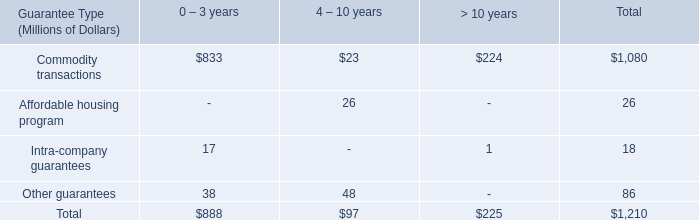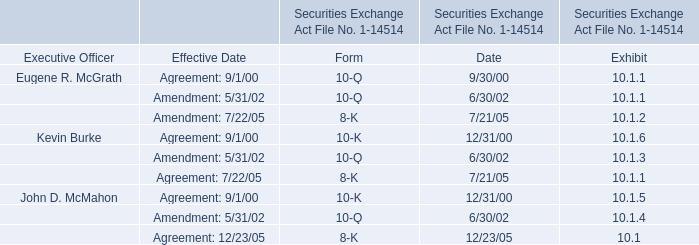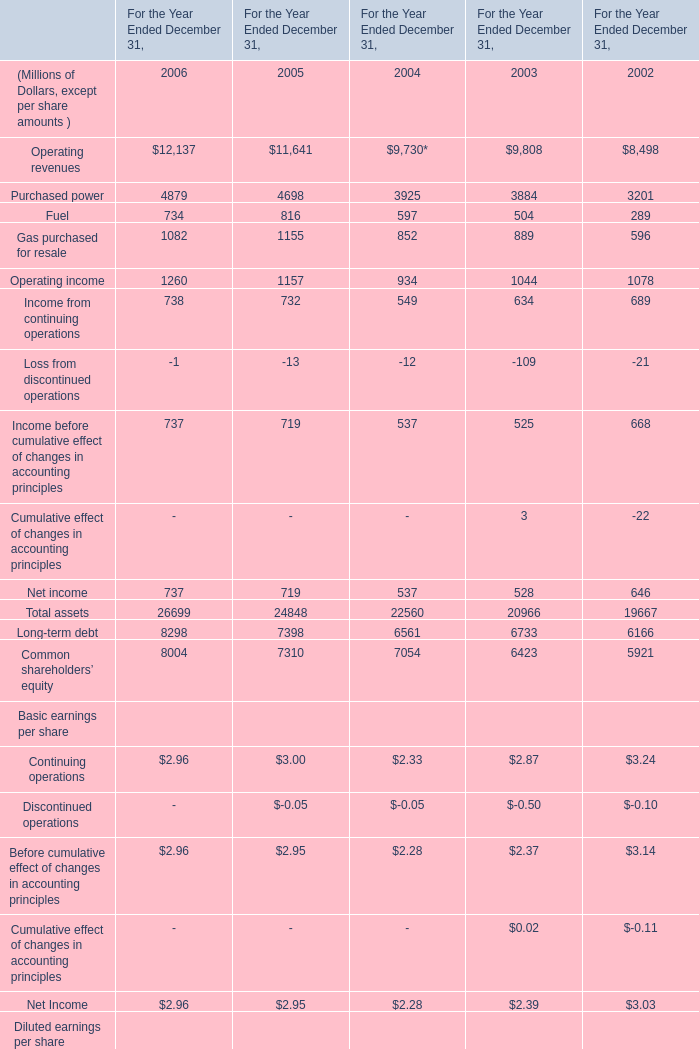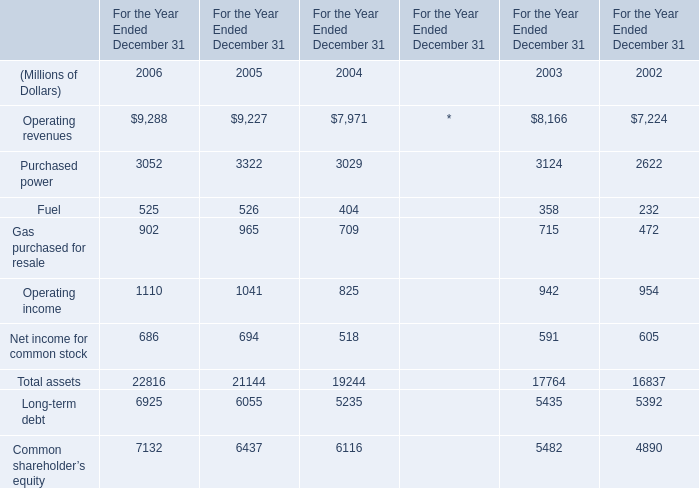What is the growing rate of Common shareholders’ equity in the year with the most Total assets? 
Computations: ((8004 - 7310) / 7310)
Answer: 0.09494. 